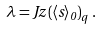<formula> <loc_0><loc_0><loc_500><loc_500>\lambda = J z \left ( \left < s \right > _ { 0 } \right ) _ { q } \, .</formula> 